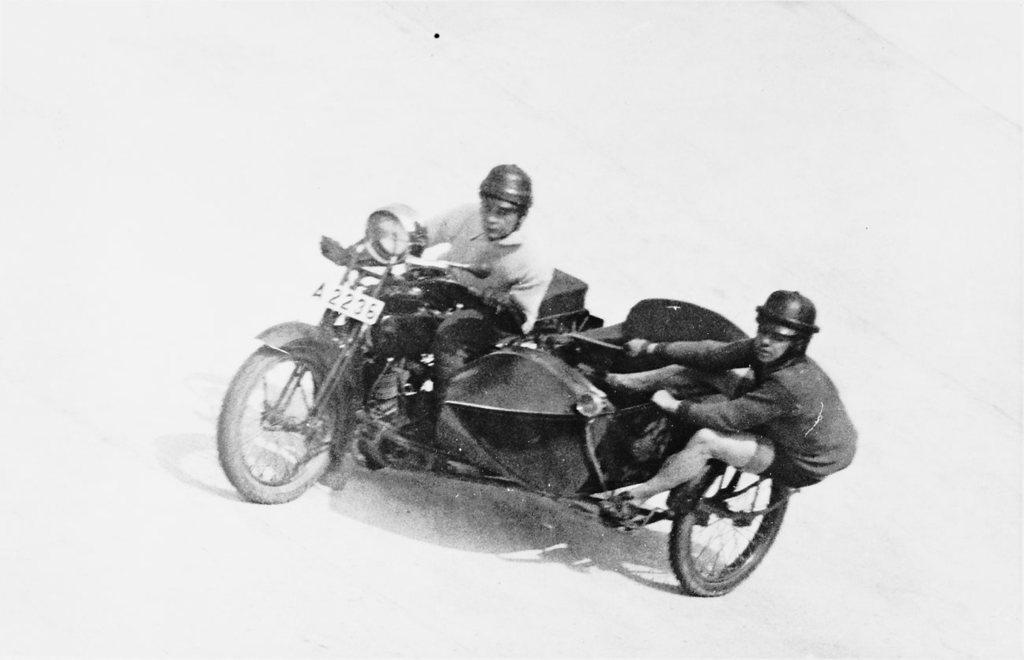How many men are present in the image? There are two men in the image. What are the two men doing in the image? The two men are riding on a vehicle. What is the color scheme of the image? The image is black and white. What time of day is it in the image, and are there any lizards present? The time of day is not mentioned in the image, and there are no lizards present. 